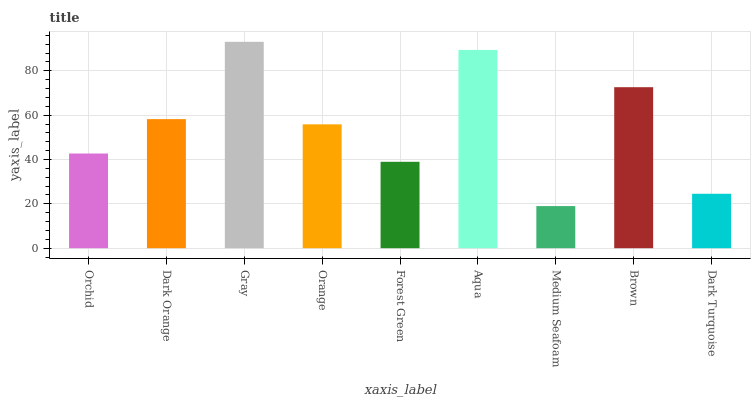Is Medium Seafoam the minimum?
Answer yes or no. Yes. Is Gray the maximum?
Answer yes or no. Yes. Is Dark Orange the minimum?
Answer yes or no. No. Is Dark Orange the maximum?
Answer yes or no. No. Is Dark Orange greater than Orchid?
Answer yes or no. Yes. Is Orchid less than Dark Orange?
Answer yes or no. Yes. Is Orchid greater than Dark Orange?
Answer yes or no. No. Is Dark Orange less than Orchid?
Answer yes or no. No. Is Orange the high median?
Answer yes or no. Yes. Is Orange the low median?
Answer yes or no. Yes. Is Dark Orange the high median?
Answer yes or no. No. Is Dark Orange the low median?
Answer yes or no. No. 